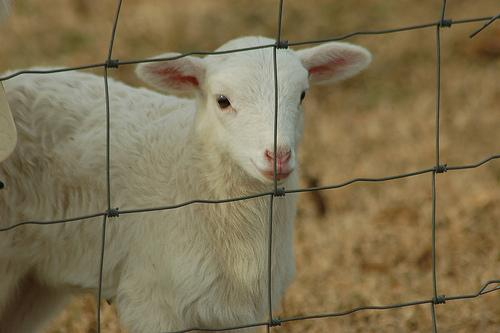Narrate the scene in the image concisely. A fenced-in white lamb with black eyes, pink nose, and pink ears rests in a field of brown grass. Please provide a description of the animal and its setting in the image. A white lamb with pink ears, nose, and mouth, and black eyes is situated behind a metal wire fence in a field of brown grass. What are the key elements in the image, and what is their relationship with each other? A white lamb with pink features and black eyes is contained within a metal wire fence in a field of brown grass. What is the primary focus of the image, and what is its action or state? A white lamb behind a metal wire fence in a yellow field with brown grass, having pink inside its ears, a pink mouth and nose, and black eyes. Can you provide a brief account of the main object and its surroundings in the image? A white lamb with pink ears, nose, and mouth, and black eyes, enclosed by a wire fence in a brown grassy area. Provide a concise rundown of the key components in the image. The image shows a white lamb with pink and black features behind a wire fence in a brown grass field. Can you summarize the content of the image in a brief sentence? A white lamb with pink and black facial features, is behind a wire fence in a field with brown grass. What is the most important component in the image, and what is its place in the scene? A white lamb with black eyes and pink features, located behind a metal wire fence in a field with patches of brown grass. In a few words, describe the animal in the image and its environment. White lamb with pink and black details inside a wire fence surrounded by brown grass. Quickly describe the central subject of the image and its context. A white lamb with pink and black facial features is behind a wire fence in a field comprising brown grass. 